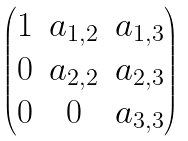Convert formula to latex. <formula><loc_0><loc_0><loc_500><loc_500>\begin{pmatrix} 1 & a _ { 1 , 2 } & a _ { 1 , 3 } \\ 0 & a _ { 2 , 2 } & a _ { 2 , 3 } \\ 0 & 0 & a _ { 3 , 3 } \end{pmatrix}</formula> 